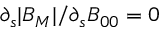Convert formula to latex. <formula><loc_0><loc_0><loc_500><loc_500>\partial _ { s } | B _ { M } | / \partial _ { s } B _ { 0 0 } = 0</formula> 